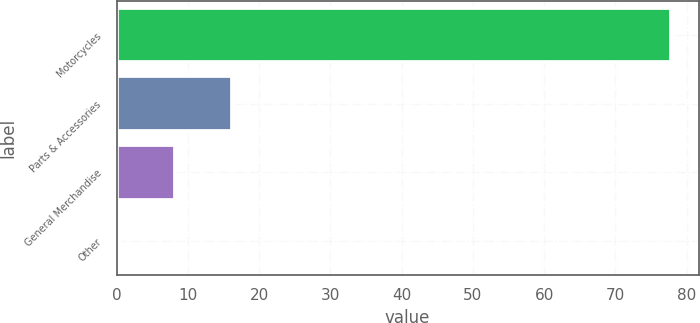<chart> <loc_0><loc_0><loc_500><loc_500><bar_chart><fcel>Motorcycles<fcel>Parts & Accessories<fcel>General Merchandise<fcel>Other<nl><fcel>77.8<fcel>16.2<fcel>8.23<fcel>0.5<nl></chart> 